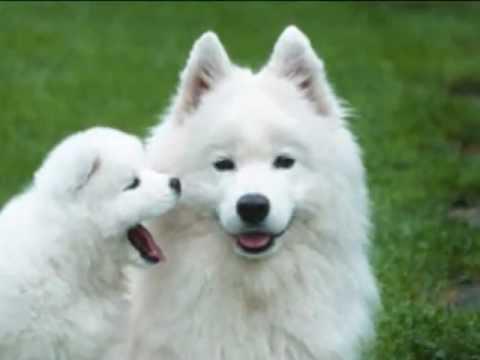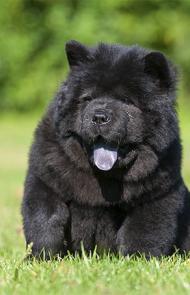The first image is the image on the left, the second image is the image on the right. Examine the images to the left and right. Is the description "There is one black dog" accurate? Answer yes or no. Yes. 